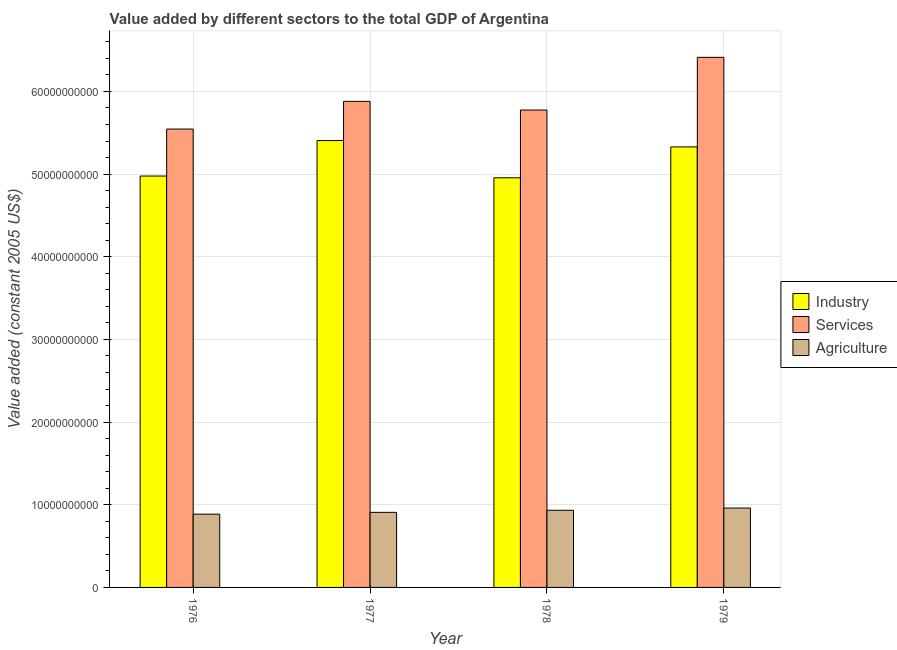How many different coloured bars are there?
Provide a succinct answer. 3. What is the label of the 1st group of bars from the left?
Your answer should be compact. 1976. What is the value added by industrial sector in 1977?
Your answer should be very brief. 5.41e+1. Across all years, what is the maximum value added by industrial sector?
Ensure brevity in your answer.  5.41e+1. Across all years, what is the minimum value added by industrial sector?
Provide a short and direct response. 4.96e+1. In which year was the value added by services maximum?
Offer a terse response. 1979. In which year was the value added by services minimum?
Your answer should be compact. 1976. What is the total value added by industrial sector in the graph?
Give a very brief answer. 2.07e+11. What is the difference between the value added by agricultural sector in 1978 and that in 1979?
Ensure brevity in your answer.  -2.67e+08. What is the difference between the value added by agricultural sector in 1978 and the value added by industrial sector in 1977?
Offer a very short reply. 2.53e+08. What is the average value added by agricultural sector per year?
Your answer should be compact. 9.22e+09. In how many years, is the value added by industrial sector greater than 4000000000 US$?
Provide a succinct answer. 4. What is the ratio of the value added by agricultural sector in 1976 to that in 1978?
Your answer should be compact. 0.95. What is the difference between the highest and the second highest value added by services?
Keep it short and to the point. 5.32e+09. What is the difference between the highest and the lowest value added by agricultural sector?
Ensure brevity in your answer.  7.37e+08. In how many years, is the value added by industrial sector greater than the average value added by industrial sector taken over all years?
Make the answer very short. 2. What does the 3rd bar from the left in 1977 represents?
Your response must be concise. Agriculture. What does the 3rd bar from the right in 1977 represents?
Your answer should be very brief. Industry. How many bars are there?
Offer a very short reply. 12. Are all the bars in the graph horizontal?
Provide a short and direct response. No. How many years are there in the graph?
Keep it short and to the point. 4. What is the difference between two consecutive major ticks on the Y-axis?
Offer a very short reply. 1.00e+1. Does the graph contain any zero values?
Your answer should be very brief. No. Where does the legend appear in the graph?
Make the answer very short. Center right. How are the legend labels stacked?
Provide a short and direct response. Vertical. What is the title of the graph?
Ensure brevity in your answer.  Value added by different sectors to the total GDP of Argentina. Does "Solid fuel" appear as one of the legend labels in the graph?
Ensure brevity in your answer.  No. What is the label or title of the Y-axis?
Make the answer very short. Value added (constant 2005 US$). What is the Value added (constant 2005 US$) of Industry in 1976?
Offer a very short reply. 4.98e+1. What is the Value added (constant 2005 US$) in Services in 1976?
Make the answer very short. 5.55e+1. What is the Value added (constant 2005 US$) of Agriculture in 1976?
Provide a succinct answer. 8.86e+09. What is the Value added (constant 2005 US$) of Industry in 1977?
Make the answer very short. 5.41e+1. What is the Value added (constant 2005 US$) in Services in 1977?
Ensure brevity in your answer.  5.88e+1. What is the Value added (constant 2005 US$) of Agriculture in 1977?
Give a very brief answer. 9.08e+09. What is the Value added (constant 2005 US$) in Industry in 1978?
Provide a succinct answer. 4.96e+1. What is the Value added (constant 2005 US$) in Services in 1978?
Your response must be concise. 5.78e+1. What is the Value added (constant 2005 US$) of Agriculture in 1978?
Offer a terse response. 9.33e+09. What is the Value added (constant 2005 US$) of Industry in 1979?
Keep it short and to the point. 5.33e+1. What is the Value added (constant 2005 US$) of Services in 1979?
Provide a succinct answer. 6.41e+1. What is the Value added (constant 2005 US$) in Agriculture in 1979?
Offer a very short reply. 9.60e+09. Across all years, what is the maximum Value added (constant 2005 US$) of Industry?
Offer a terse response. 5.41e+1. Across all years, what is the maximum Value added (constant 2005 US$) in Services?
Ensure brevity in your answer.  6.41e+1. Across all years, what is the maximum Value added (constant 2005 US$) in Agriculture?
Make the answer very short. 9.60e+09. Across all years, what is the minimum Value added (constant 2005 US$) of Industry?
Your answer should be very brief. 4.96e+1. Across all years, what is the minimum Value added (constant 2005 US$) of Services?
Your answer should be compact. 5.55e+1. Across all years, what is the minimum Value added (constant 2005 US$) of Agriculture?
Make the answer very short. 8.86e+09. What is the total Value added (constant 2005 US$) of Industry in the graph?
Provide a succinct answer. 2.07e+11. What is the total Value added (constant 2005 US$) of Services in the graph?
Your answer should be compact. 2.36e+11. What is the total Value added (constant 2005 US$) of Agriculture in the graph?
Provide a short and direct response. 3.69e+1. What is the difference between the Value added (constant 2005 US$) of Industry in 1976 and that in 1977?
Ensure brevity in your answer.  -4.29e+09. What is the difference between the Value added (constant 2005 US$) of Services in 1976 and that in 1977?
Your answer should be compact. -3.35e+09. What is the difference between the Value added (constant 2005 US$) in Agriculture in 1976 and that in 1977?
Give a very brief answer. -2.17e+08. What is the difference between the Value added (constant 2005 US$) of Industry in 1976 and that in 1978?
Offer a terse response. 2.12e+08. What is the difference between the Value added (constant 2005 US$) of Services in 1976 and that in 1978?
Make the answer very short. -2.30e+09. What is the difference between the Value added (constant 2005 US$) in Agriculture in 1976 and that in 1978?
Offer a terse response. -4.70e+08. What is the difference between the Value added (constant 2005 US$) of Industry in 1976 and that in 1979?
Provide a short and direct response. -3.53e+09. What is the difference between the Value added (constant 2005 US$) of Services in 1976 and that in 1979?
Provide a succinct answer. -8.68e+09. What is the difference between the Value added (constant 2005 US$) of Agriculture in 1976 and that in 1979?
Your answer should be compact. -7.37e+08. What is the difference between the Value added (constant 2005 US$) of Industry in 1977 and that in 1978?
Offer a very short reply. 4.51e+09. What is the difference between the Value added (constant 2005 US$) of Services in 1977 and that in 1978?
Give a very brief answer. 1.05e+09. What is the difference between the Value added (constant 2005 US$) of Agriculture in 1977 and that in 1978?
Provide a short and direct response. -2.53e+08. What is the difference between the Value added (constant 2005 US$) of Industry in 1977 and that in 1979?
Keep it short and to the point. 7.69e+08. What is the difference between the Value added (constant 2005 US$) of Services in 1977 and that in 1979?
Provide a short and direct response. -5.32e+09. What is the difference between the Value added (constant 2005 US$) in Agriculture in 1977 and that in 1979?
Provide a succinct answer. -5.20e+08. What is the difference between the Value added (constant 2005 US$) in Industry in 1978 and that in 1979?
Your answer should be very brief. -3.74e+09. What is the difference between the Value added (constant 2005 US$) of Services in 1978 and that in 1979?
Ensure brevity in your answer.  -6.38e+09. What is the difference between the Value added (constant 2005 US$) of Agriculture in 1978 and that in 1979?
Keep it short and to the point. -2.67e+08. What is the difference between the Value added (constant 2005 US$) of Industry in 1976 and the Value added (constant 2005 US$) of Services in 1977?
Your response must be concise. -9.04e+09. What is the difference between the Value added (constant 2005 US$) of Industry in 1976 and the Value added (constant 2005 US$) of Agriculture in 1977?
Give a very brief answer. 4.07e+1. What is the difference between the Value added (constant 2005 US$) of Services in 1976 and the Value added (constant 2005 US$) of Agriculture in 1977?
Give a very brief answer. 4.64e+1. What is the difference between the Value added (constant 2005 US$) in Industry in 1976 and the Value added (constant 2005 US$) in Services in 1978?
Offer a terse response. -7.99e+09. What is the difference between the Value added (constant 2005 US$) of Industry in 1976 and the Value added (constant 2005 US$) of Agriculture in 1978?
Provide a succinct answer. 4.04e+1. What is the difference between the Value added (constant 2005 US$) in Services in 1976 and the Value added (constant 2005 US$) in Agriculture in 1978?
Offer a very short reply. 4.61e+1. What is the difference between the Value added (constant 2005 US$) of Industry in 1976 and the Value added (constant 2005 US$) of Services in 1979?
Ensure brevity in your answer.  -1.44e+1. What is the difference between the Value added (constant 2005 US$) of Industry in 1976 and the Value added (constant 2005 US$) of Agriculture in 1979?
Offer a very short reply. 4.02e+1. What is the difference between the Value added (constant 2005 US$) in Services in 1976 and the Value added (constant 2005 US$) in Agriculture in 1979?
Your answer should be compact. 4.58e+1. What is the difference between the Value added (constant 2005 US$) in Industry in 1977 and the Value added (constant 2005 US$) in Services in 1978?
Offer a very short reply. -3.69e+09. What is the difference between the Value added (constant 2005 US$) in Industry in 1977 and the Value added (constant 2005 US$) in Agriculture in 1978?
Offer a very short reply. 4.47e+1. What is the difference between the Value added (constant 2005 US$) of Services in 1977 and the Value added (constant 2005 US$) of Agriculture in 1978?
Offer a terse response. 4.95e+1. What is the difference between the Value added (constant 2005 US$) of Industry in 1977 and the Value added (constant 2005 US$) of Services in 1979?
Make the answer very short. -1.01e+1. What is the difference between the Value added (constant 2005 US$) of Industry in 1977 and the Value added (constant 2005 US$) of Agriculture in 1979?
Your response must be concise. 4.45e+1. What is the difference between the Value added (constant 2005 US$) of Services in 1977 and the Value added (constant 2005 US$) of Agriculture in 1979?
Provide a succinct answer. 4.92e+1. What is the difference between the Value added (constant 2005 US$) in Industry in 1978 and the Value added (constant 2005 US$) in Services in 1979?
Offer a very short reply. -1.46e+1. What is the difference between the Value added (constant 2005 US$) of Industry in 1978 and the Value added (constant 2005 US$) of Agriculture in 1979?
Offer a terse response. 4.00e+1. What is the difference between the Value added (constant 2005 US$) in Services in 1978 and the Value added (constant 2005 US$) in Agriculture in 1979?
Ensure brevity in your answer.  4.82e+1. What is the average Value added (constant 2005 US$) of Industry per year?
Provide a short and direct response. 5.17e+1. What is the average Value added (constant 2005 US$) of Services per year?
Provide a short and direct response. 5.90e+1. What is the average Value added (constant 2005 US$) of Agriculture per year?
Offer a terse response. 9.22e+09. In the year 1976, what is the difference between the Value added (constant 2005 US$) of Industry and Value added (constant 2005 US$) of Services?
Make the answer very short. -5.68e+09. In the year 1976, what is the difference between the Value added (constant 2005 US$) of Industry and Value added (constant 2005 US$) of Agriculture?
Provide a short and direct response. 4.09e+1. In the year 1976, what is the difference between the Value added (constant 2005 US$) in Services and Value added (constant 2005 US$) in Agriculture?
Ensure brevity in your answer.  4.66e+1. In the year 1977, what is the difference between the Value added (constant 2005 US$) of Industry and Value added (constant 2005 US$) of Services?
Offer a terse response. -4.74e+09. In the year 1977, what is the difference between the Value added (constant 2005 US$) of Industry and Value added (constant 2005 US$) of Agriculture?
Your response must be concise. 4.50e+1. In the year 1977, what is the difference between the Value added (constant 2005 US$) of Services and Value added (constant 2005 US$) of Agriculture?
Provide a short and direct response. 4.97e+1. In the year 1978, what is the difference between the Value added (constant 2005 US$) in Industry and Value added (constant 2005 US$) in Services?
Give a very brief answer. -8.20e+09. In the year 1978, what is the difference between the Value added (constant 2005 US$) of Industry and Value added (constant 2005 US$) of Agriculture?
Your answer should be compact. 4.02e+1. In the year 1978, what is the difference between the Value added (constant 2005 US$) in Services and Value added (constant 2005 US$) in Agriculture?
Offer a very short reply. 4.84e+1. In the year 1979, what is the difference between the Value added (constant 2005 US$) of Industry and Value added (constant 2005 US$) of Services?
Provide a short and direct response. -1.08e+1. In the year 1979, what is the difference between the Value added (constant 2005 US$) of Industry and Value added (constant 2005 US$) of Agriculture?
Your answer should be very brief. 4.37e+1. In the year 1979, what is the difference between the Value added (constant 2005 US$) in Services and Value added (constant 2005 US$) in Agriculture?
Provide a short and direct response. 5.45e+1. What is the ratio of the Value added (constant 2005 US$) in Industry in 1976 to that in 1977?
Offer a terse response. 0.92. What is the ratio of the Value added (constant 2005 US$) of Services in 1976 to that in 1977?
Your answer should be compact. 0.94. What is the ratio of the Value added (constant 2005 US$) of Agriculture in 1976 to that in 1977?
Offer a terse response. 0.98. What is the ratio of the Value added (constant 2005 US$) in Industry in 1976 to that in 1978?
Your answer should be compact. 1. What is the ratio of the Value added (constant 2005 US$) of Services in 1976 to that in 1978?
Give a very brief answer. 0.96. What is the ratio of the Value added (constant 2005 US$) of Agriculture in 1976 to that in 1978?
Provide a short and direct response. 0.95. What is the ratio of the Value added (constant 2005 US$) of Industry in 1976 to that in 1979?
Offer a terse response. 0.93. What is the ratio of the Value added (constant 2005 US$) in Services in 1976 to that in 1979?
Ensure brevity in your answer.  0.86. What is the ratio of the Value added (constant 2005 US$) of Agriculture in 1976 to that in 1979?
Your answer should be very brief. 0.92. What is the ratio of the Value added (constant 2005 US$) in Industry in 1977 to that in 1978?
Provide a succinct answer. 1.09. What is the ratio of the Value added (constant 2005 US$) in Services in 1977 to that in 1978?
Your response must be concise. 1.02. What is the ratio of the Value added (constant 2005 US$) of Agriculture in 1977 to that in 1978?
Offer a terse response. 0.97. What is the ratio of the Value added (constant 2005 US$) of Industry in 1977 to that in 1979?
Make the answer very short. 1.01. What is the ratio of the Value added (constant 2005 US$) in Services in 1977 to that in 1979?
Your response must be concise. 0.92. What is the ratio of the Value added (constant 2005 US$) in Agriculture in 1977 to that in 1979?
Give a very brief answer. 0.95. What is the ratio of the Value added (constant 2005 US$) in Industry in 1978 to that in 1979?
Offer a terse response. 0.93. What is the ratio of the Value added (constant 2005 US$) of Services in 1978 to that in 1979?
Make the answer very short. 0.9. What is the ratio of the Value added (constant 2005 US$) of Agriculture in 1978 to that in 1979?
Give a very brief answer. 0.97. What is the difference between the highest and the second highest Value added (constant 2005 US$) in Industry?
Your answer should be very brief. 7.69e+08. What is the difference between the highest and the second highest Value added (constant 2005 US$) of Services?
Provide a short and direct response. 5.32e+09. What is the difference between the highest and the second highest Value added (constant 2005 US$) of Agriculture?
Make the answer very short. 2.67e+08. What is the difference between the highest and the lowest Value added (constant 2005 US$) of Industry?
Ensure brevity in your answer.  4.51e+09. What is the difference between the highest and the lowest Value added (constant 2005 US$) of Services?
Make the answer very short. 8.68e+09. What is the difference between the highest and the lowest Value added (constant 2005 US$) in Agriculture?
Offer a terse response. 7.37e+08. 